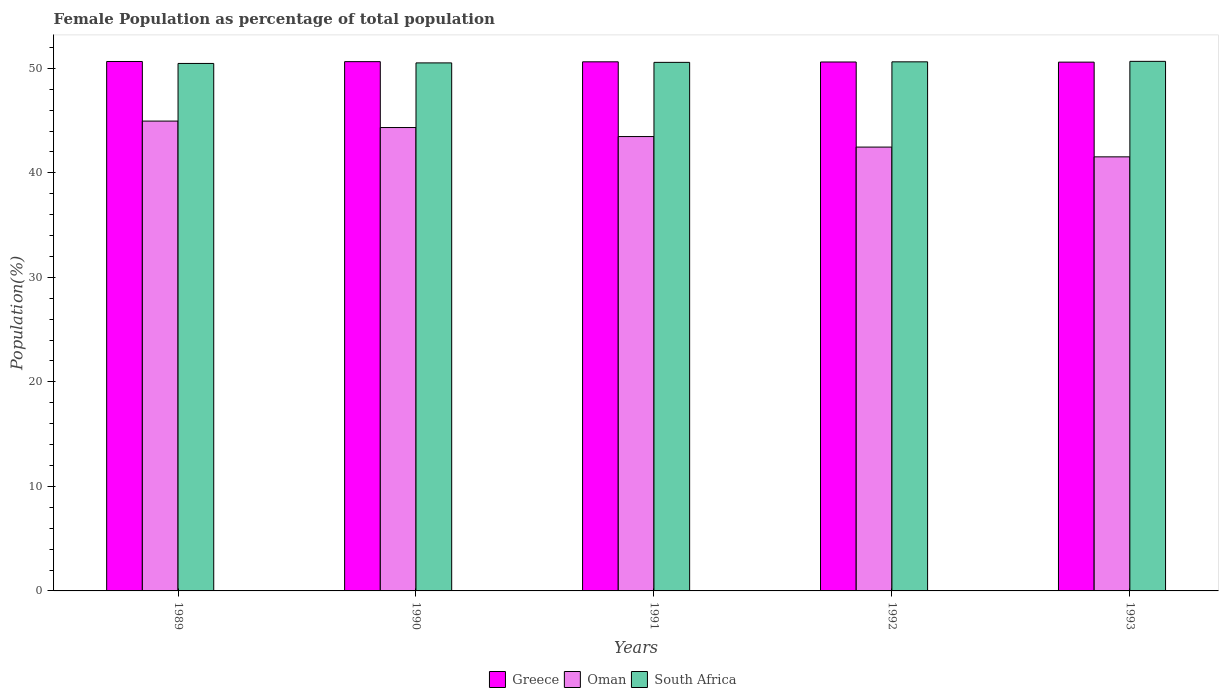What is the label of the 5th group of bars from the left?
Offer a very short reply. 1993. In how many cases, is the number of bars for a given year not equal to the number of legend labels?
Keep it short and to the point. 0. What is the female population in in Oman in 1991?
Your answer should be compact. 43.47. Across all years, what is the maximum female population in in Greece?
Make the answer very short. 50.66. Across all years, what is the minimum female population in in South Africa?
Keep it short and to the point. 50.47. In which year was the female population in in Oman maximum?
Your answer should be compact. 1989. In which year was the female population in in Greece minimum?
Offer a very short reply. 1993. What is the total female population in in Greece in the graph?
Provide a succinct answer. 253.13. What is the difference between the female population in in Oman in 1990 and that in 1991?
Your response must be concise. 0.86. What is the difference between the female population in in Greece in 1992 and the female population in in South Africa in 1989?
Ensure brevity in your answer.  0.14. What is the average female population in in Greece per year?
Make the answer very short. 50.63. In the year 1993, what is the difference between the female population in in South Africa and female population in in Greece?
Make the answer very short. 0.08. What is the ratio of the female population in in Greece in 1989 to that in 1992?
Make the answer very short. 1. Is the female population in in Greece in 1989 less than that in 1992?
Give a very brief answer. No. Is the difference between the female population in in South Africa in 1989 and 1991 greater than the difference between the female population in in Greece in 1989 and 1991?
Offer a very short reply. No. What is the difference between the highest and the second highest female population in in South Africa?
Give a very brief answer. 0.05. What is the difference between the highest and the lowest female population in in Greece?
Your answer should be very brief. 0.06. Is the sum of the female population in in Greece in 1991 and 1992 greater than the maximum female population in in South Africa across all years?
Make the answer very short. Yes. What does the 3rd bar from the left in 1993 represents?
Offer a terse response. South Africa. What does the 3rd bar from the right in 1992 represents?
Make the answer very short. Greece. Is it the case that in every year, the sum of the female population in in South Africa and female population in in Oman is greater than the female population in in Greece?
Ensure brevity in your answer.  Yes. How many bars are there?
Provide a succinct answer. 15. Are all the bars in the graph horizontal?
Keep it short and to the point. No. How many years are there in the graph?
Make the answer very short. 5. What is the difference between two consecutive major ticks on the Y-axis?
Keep it short and to the point. 10. Are the values on the major ticks of Y-axis written in scientific E-notation?
Keep it short and to the point. No. Does the graph contain grids?
Make the answer very short. No. How many legend labels are there?
Ensure brevity in your answer.  3. How are the legend labels stacked?
Offer a terse response. Horizontal. What is the title of the graph?
Make the answer very short. Female Population as percentage of total population. What is the label or title of the X-axis?
Provide a succinct answer. Years. What is the label or title of the Y-axis?
Provide a short and direct response. Population(%). What is the Population(%) in Greece in 1989?
Your response must be concise. 50.66. What is the Population(%) of Oman in 1989?
Make the answer very short. 44.96. What is the Population(%) of South Africa in 1989?
Your answer should be very brief. 50.47. What is the Population(%) in Greece in 1990?
Your answer should be compact. 50.64. What is the Population(%) in Oman in 1990?
Provide a succinct answer. 44.34. What is the Population(%) of South Africa in 1990?
Your response must be concise. 50.52. What is the Population(%) of Greece in 1991?
Provide a succinct answer. 50.63. What is the Population(%) of Oman in 1991?
Your answer should be compact. 43.47. What is the Population(%) of South Africa in 1991?
Keep it short and to the point. 50.57. What is the Population(%) of Greece in 1992?
Offer a very short reply. 50.61. What is the Population(%) in Oman in 1992?
Offer a very short reply. 42.47. What is the Population(%) in South Africa in 1992?
Your response must be concise. 50.63. What is the Population(%) in Greece in 1993?
Offer a very short reply. 50.6. What is the Population(%) in Oman in 1993?
Keep it short and to the point. 41.53. What is the Population(%) in South Africa in 1993?
Give a very brief answer. 50.67. Across all years, what is the maximum Population(%) in Greece?
Your response must be concise. 50.66. Across all years, what is the maximum Population(%) of Oman?
Make the answer very short. 44.96. Across all years, what is the maximum Population(%) of South Africa?
Your answer should be very brief. 50.67. Across all years, what is the minimum Population(%) of Greece?
Offer a very short reply. 50.6. Across all years, what is the minimum Population(%) of Oman?
Your response must be concise. 41.53. Across all years, what is the minimum Population(%) in South Africa?
Your response must be concise. 50.47. What is the total Population(%) of Greece in the graph?
Your answer should be very brief. 253.13. What is the total Population(%) in Oman in the graph?
Make the answer very short. 216.77. What is the total Population(%) of South Africa in the graph?
Your response must be concise. 252.86. What is the difference between the Population(%) of Greece in 1989 and that in 1990?
Keep it short and to the point. 0.02. What is the difference between the Population(%) of Oman in 1989 and that in 1990?
Your answer should be very brief. 0.62. What is the difference between the Population(%) of South Africa in 1989 and that in 1990?
Your answer should be very brief. -0.05. What is the difference between the Population(%) in Greece in 1989 and that in 1991?
Give a very brief answer. 0.03. What is the difference between the Population(%) in Oman in 1989 and that in 1991?
Your response must be concise. 1.48. What is the difference between the Population(%) of South Africa in 1989 and that in 1991?
Your response must be concise. -0.1. What is the difference between the Population(%) of Greece in 1989 and that in 1992?
Make the answer very short. 0.05. What is the difference between the Population(%) in Oman in 1989 and that in 1992?
Make the answer very short. 2.49. What is the difference between the Population(%) of South Africa in 1989 and that in 1992?
Make the answer very short. -0.15. What is the difference between the Population(%) in Greece in 1989 and that in 1993?
Offer a terse response. 0.06. What is the difference between the Population(%) of Oman in 1989 and that in 1993?
Make the answer very short. 3.42. What is the difference between the Population(%) in Greece in 1990 and that in 1991?
Your answer should be compact. 0.02. What is the difference between the Population(%) of Oman in 1990 and that in 1991?
Offer a very short reply. 0.86. What is the difference between the Population(%) in South Africa in 1990 and that in 1991?
Give a very brief answer. -0.05. What is the difference between the Population(%) of Greece in 1990 and that in 1992?
Give a very brief answer. 0.03. What is the difference between the Population(%) in Oman in 1990 and that in 1992?
Provide a short and direct response. 1.87. What is the difference between the Population(%) of South Africa in 1990 and that in 1992?
Offer a very short reply. -0.1. What is the difference between the Population(%) of Greece in 1990 and that in 1993?
Your response must be concise. 0.05. What is the difference between the Population(%) in Oman in 1990 and that in 1993?
Make the answer very short. 2.8. What is the difference between the Population(%) in South Africa in 1990 and that in 1993?
Provide a short and direct response. -0.15. What is the difference between the Population(%) in Greece in 1991 and that in 1992?
Make the answer very short. 0.02. What is the difference between the Population(%) of Oman in 1991 and that in 1992?
Your answer should be compact. 1.01. What is the difference between the Population(%) of South Africa in 1991 and that in 1992?
Your answer should be compact. -0.05. What is the difference between the Population(%) in Greece in 1991 and that in 1993?
Give a very brief answer. 0.03. What is the difference between the Population(%) in Oman in 1991 and that in 1993?
Offer a terse response. 1.94. What is the difference between the Population(%) of South Africa in 1991 and that in 1993?
Offer a very short reply. -0.1. What is the difference between the Population(%) in Greece in 1992 and that in 1993?
Keep it short and to the point. 0.01. What is the difference between the Population(%) of Oman in 1992 and that in 1993?
Provide a succinct answer. 0.93. What is the difference between the Population(%) in South Africa in 1992 and that in 1993?
Ensure brevity in your answer.  -0.05. What is the difference between the Population(%) in Greece in 1989 and the Population(%) in Oman in 1990?
Your response must be concise. 6.32. What is the difference between the Population(%) of Greece in 1989 and the Population(%) of South Africa in 1990?
Ensure brevity in your answer.  0.14. What is the difference between the Population(%) of Oman in 1989 and the Population(%) of South Africa in 1990?
Your answer should be very brief. -5.57. What is the difference between the Population(%) of Greece in 1989 and the Population(%) of Oman in 1991?
Ensure brevity in your answer.  7.18. What is the difference between the Population(%) of Greece in 1989 and the Population(%) of South Africa in 1991?
Your answer should be very brief. 0.08. What is the difference between the Population(%) in Oman in 1989 and the Population(%) in South Africa in 1991?
Give a very brief answer. -5.62. What is the difference between the Population(%) in Greece in 1989 and the Population(%) in Oman in 1992?
Give a very brief answer. 8.19. What is the difference between the Population(%) of Greece in 1989 and the Population(%) of South Africa in 1992?
Your answer should be very brief. 0.03. What is the difference between the Population(%) in Oman in 1989 and the Population(%) in South Africa in 1992?
Provide a succinct answer. -5.67. What is the difference between the Population(%) in Greece in 1989 and the Population(%) in Oman in 1993?
Your response must be concise. 9.12. What is the difference between the Population(%) of Greece in 1989 and the Population(%) of South Africa in 1993?
Your response must be concise. -0.01. What is the difference between the Population(%) of Oman in 1989 and the Population(%) of South Africa in 1993?
Offer a very short reply. -5.72. What is the difference between the Population(%) in Greece in 1990 and the Population(%) in Oman in 1991?
Provide a succinct answer. 7.17. What is the difference between the Population(%) of Greece in 1990 and the Population(%) of South Africa in 1991?
Make the answer very short. 0.07. What is the difference between the Population(%) of Oman in 1990 and the Population(%) of South Africa in 1991?
Make the answer very short. -6.24. What is the difference between the Population(%) in Greece in 1990 and the Population(%) in Oman in 1992?
Provide a succinct answer. 8.18. What is the difference between the Population(%) of Greece in 1990 and the Population(%) of South Africa in 1992?
Offer a very short reply. 0.02. What is the difference between the Population(%) in Oman in 1990 and the Population(%) in South Africa in 1992?
Offer a very short reply. -6.29. What is the difference between the Population(%) of Greece in 1990 and the Population(%) of Oman in 1993?
Keep it short and to the point. 9.11. What is the difference between the Population(%) of Greece in 1990 and the Population(%) of South Africa in 1993?
Offer a very short reply. -0.03. What is the difference between the Population(%) of Oman in 1990 and the Population(%) of South Africa in 1993?
Offer a very short reply. -6.33. What is the difference between the Population(%) in Greece in 1991 and the Population(%) in Oman in 1992?
Give a very brief answer. 8.16. What is the difference between the Population(%) of Greece in 1991 and the Population(%) of South Africa in 1992?
Your answer should be compact. 0. What is the difference between the Population(%) in Oman in 1991 and the Population(%) in South Africa in 1992?
Ensure brevity in your answer.  -7.15. What is the difference between the Population(%) in Greece in 1991 and the Population(%) in Oman in 1993?
Provide a succinct answer. 9.09. What is the difference between the Population(%) of Greece in 1991 and the Population(%) of South Africa in 1993?
Keep it short and to the point. -0.04. What is the difference between the Population(%) in Oman in 1991 and the Population(%) in South Africa in 1993?
Your response must be concise. -7.2. What is the difference between the Population(%) in Greece in 1992 and the Population(%) in Oman in 1993?
Offer a very short reply. 9.08. What is the difference between the Population(%) in Greece in 1992 and the Population(%) in South Africa in 1993?
Your answer should be very brief. -0.06. What is the difference between the Population(%) of Oman in 1992 and the Population(%) of South Africa in 1993?
Make the answer very short. -8.2. What is the average Population(%) in Greece per year?
Ensure brevity in your answer.  50.63. What is the average Population(%) of Oman per year?
Make the answer very short. 43.35. What is the average Population(%) in South Africa per year?
Provide a short and direct response. 50.57. In the year 1989, what is the difference between the Population(%) of Greece and Population(%) of Oman?
Provide a succinct answer. 5.7. In the year 1989, what is the difference between the Population(%) of Greece and Population(%) of South Africa?
Offer a very short reply. 0.19. In the year 1989, what is the difference between the Population(%) in Oman and Population(%) in South Africa?
Your answer should be compact. -5.52. In the year 1990, what is the difference between the Population(%) in Greece and Population(%) in Oman?
Keep it short and to the point. 6.3. In the year 1990, what is the difference between the Population(%) in Greece and Population(%) in South Africa?
Provide a succinct answer. 0.12. In the year 1990, what is the difference between the Population(%) of Oman and Population(%) of South Africa?
Your response must be concise. -6.19. In the year 1991, what is the difference between the Population(%) of Greece and Population(%) of Oman?
Provide a succinct answer. 7.15. In the year 1991, what is the difference between the Population(%) of Greece and Population(%) of South Africa?
Provide a succinct answer. 0.05. In the year 1991, what is the difference between the Population(%) of Oman and Population(%) of South Africa?
Your answer should be very brief. -7.1. In the year 1992, what is the difference between the Population(%) of Greece and Population(%) of Oman?
Provide a short and direct response. 8.14. In the year 1992, what is the difference between the Population(%) in Greece and Population(%) in South Africa?
Offer a very short reply. -0.01. In the year 1992, what is the difference between the Population(%) in Oman and Population(%) in South Africa?
Provide a succinct answer. -8.16. In the year 1993, what is the difference between the Population(%) in Greece and Population(%) in Oman?
Ensure brevity in your answer.  9.06. In the year 1993, what is the difference between the Population(%) of Greece and Population(%) of South Africa?
Give a very brief answer. -0.08. In the year 1993, what is the difference between the Population(%) in Oman and Population(%) in South Africa?
Your answer should be compact. -9.14. What is the ratio of the Population(%) of Oman in 1989 to that in 1990?
Your response must be concise. 1.01. What is the ratio of the Population(%) in South Africa in 1989 to that in 1990?
Provide a short and direct response. 1. What is the ratio of the Population(%) in Greece in 1989 to that in 1991?
Offer a very short reply. 1. What is the ratio of the Population(%) of Oman in 1989 to that in 1991?
Make the answer very short. 1.03. What is the ratio of the Population(%) in South Africa in 1989 to that in 1991?
Your response must be concise. 1. What is the ratio of the Population(%) of Greece in 1989 to that in 1992?
Your answer should be very brief. 1. What is the ratio of the Population(%) in Oman in 1989 to that in 1992?
Give a very brief answer. 1.06. What is the ratio of the Population(%) in Greece in 1989 to that in 1993?
Offer a terse response. 1. What is the ratio of the Population(%) in Oman in 1989 to that in 1993?
Offer a terse response. 1.08. What is the ratio of the Population(%) in Greece in 1990 to that in 1991?
Your answer should be compact. 1. What is the ratio of the Population(%) of Oman in 1990 to that in 1991?
Your response must be concise. 1.02. What is the ratio of the Population(%) in South Africa in 1990 to that in 1991?
Give a very brief answer. 1. What is the ratio of the Population(%) in Greece in 1990 to that in 1992?
Give a very brief answer. 1. What is the ratio of the Population(%) of Oman in 1990 to that in 1992?
Your answer should be very brief. 1.04. What is the ratio of the Population(%) in Oman in 1990 to that in 1993?
Your answer should be compact. 1.07. What is the ratio of the Population(%) in Greece in 1991 to that in 1992?
Give a very brief answer. 1. What is the ratio of the Population(%) of Oman in 1991 to that in 1992?
Give a very brief answer. 1.02. What is the ratio of the Population(%) of Oman in 1991 to that in 1993?
Your response must be concise. 1.05. What is the ratio of the Population(%) of South Africa in 1991 to that in 1993?
Your answer should be very brief. 1. What is the ratio of the Population(%) of Greece in 1992 to that in 1993?
Keep it short and to the point. 1. What is the ratio of the Population(%) of Oman in 1992 to that in 1993?
Make the answer very short. 1.02. What is the difference between the highest and the second highest Population(%) in Greece?
Make the answer very short. 0.02. What is the difference between the highest and the second highest Population(%) in Oman?
Provide a succinct answer. 0.62. What is the difference between the highest and the second highest Population(%) in South Africa?
Offer a terse response. 0.05. What is the difference between the highest and the lowest Population(%) of Greece?
Offer a very short reply. 0.06. What is the difference between the highest and the lowest Population(%) of Oman?
Ensure brevity in your answer.  3.42. What is the difference between the highest and the lowest Population(%) of South Africa?
Offer a very short reply. 0.2. 